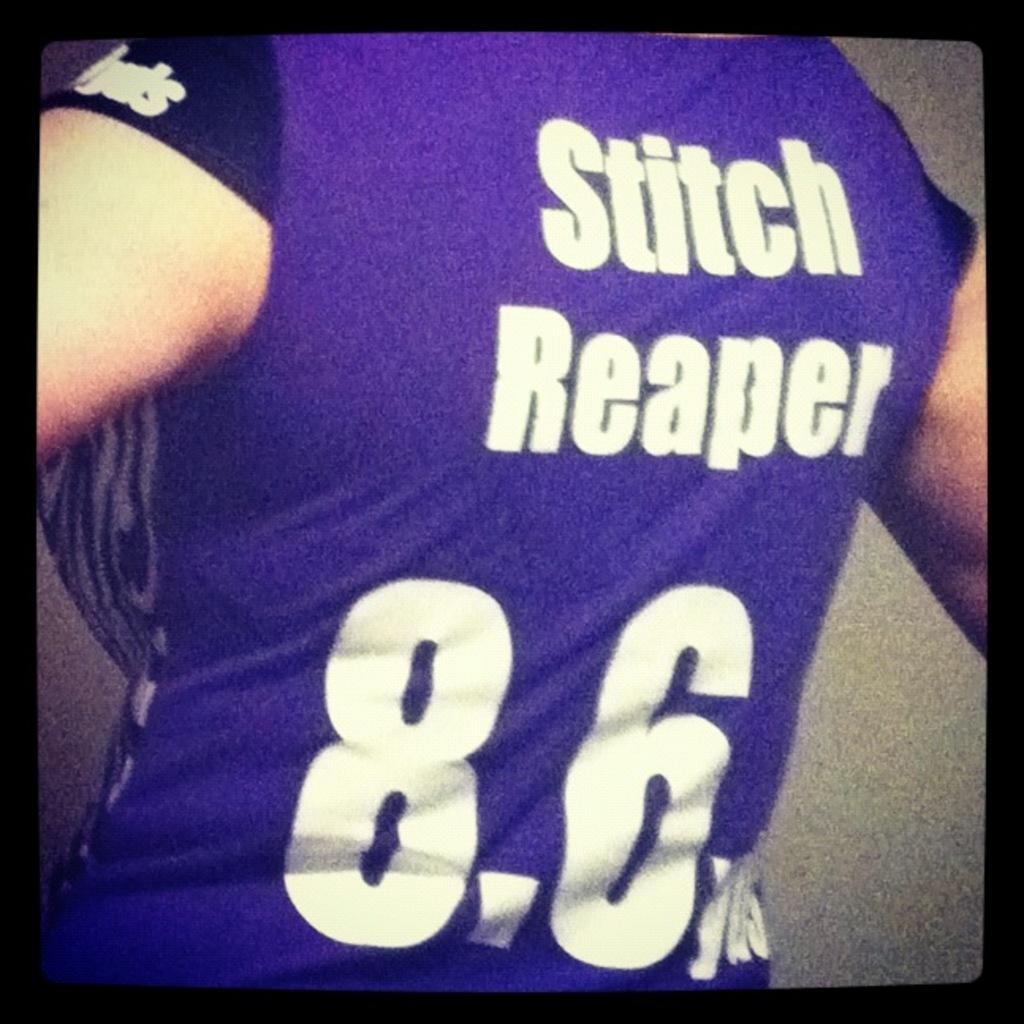<image>
Give a short and clear explanation of the subsequent image. A person is wearing a shirt that says, 'stitch reaper 8.6', on the back. 